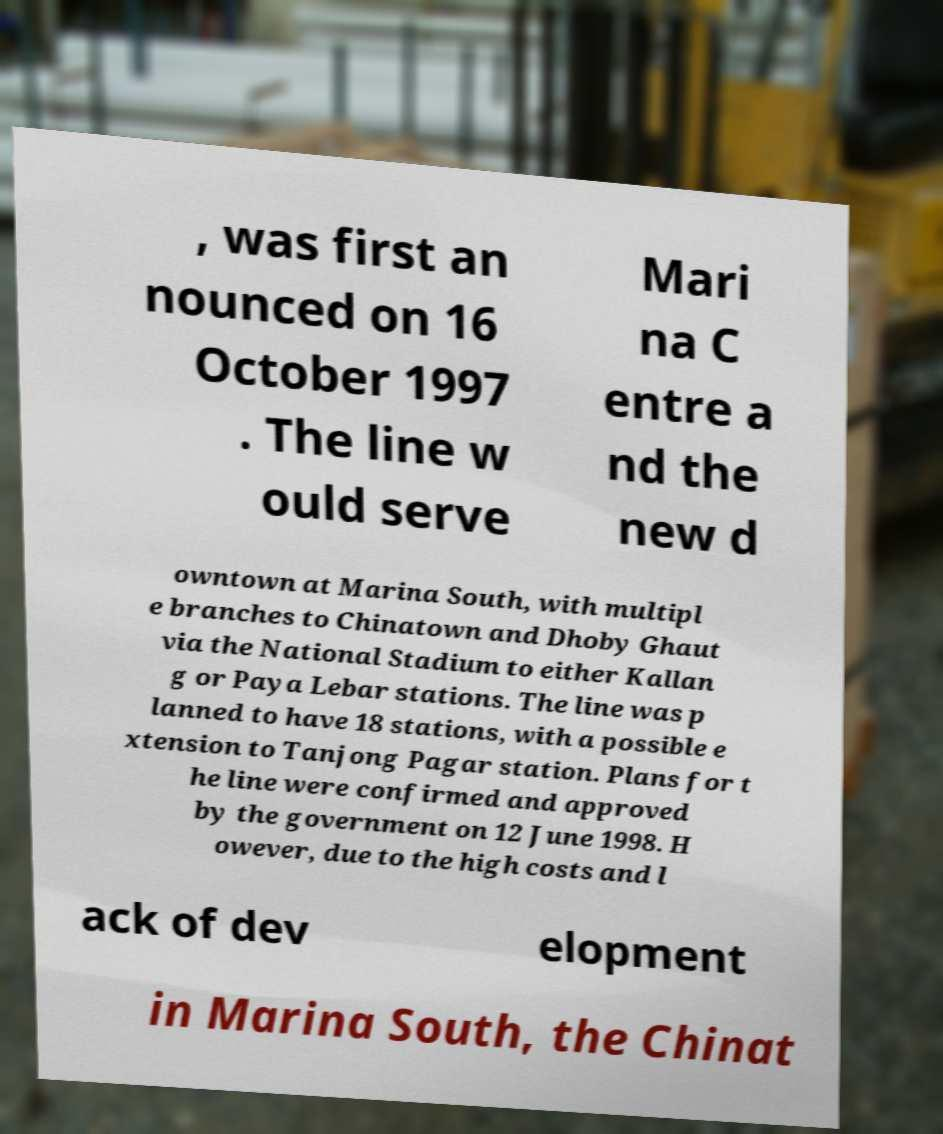What messages or text are displayed in this image? I need them in a readable, typed format. , was first an nounced on 16 October 1997 . The line w ould serve Mari na C entre a nd the new d owntown at Marina South, with multipl e branches to Chinatown and Dhoby Ghaut via the National Stadium to either Kallan g or Paya Lebar stations. The line was p lanned to have 18 stations, with a possible e xtension to Tanjong Pagar station. Plans for t he line were confirmed and approved by the government on 12 June 1998. H owever, due to the high costs and l ack of dev elopment in Marina South, the Chinat 